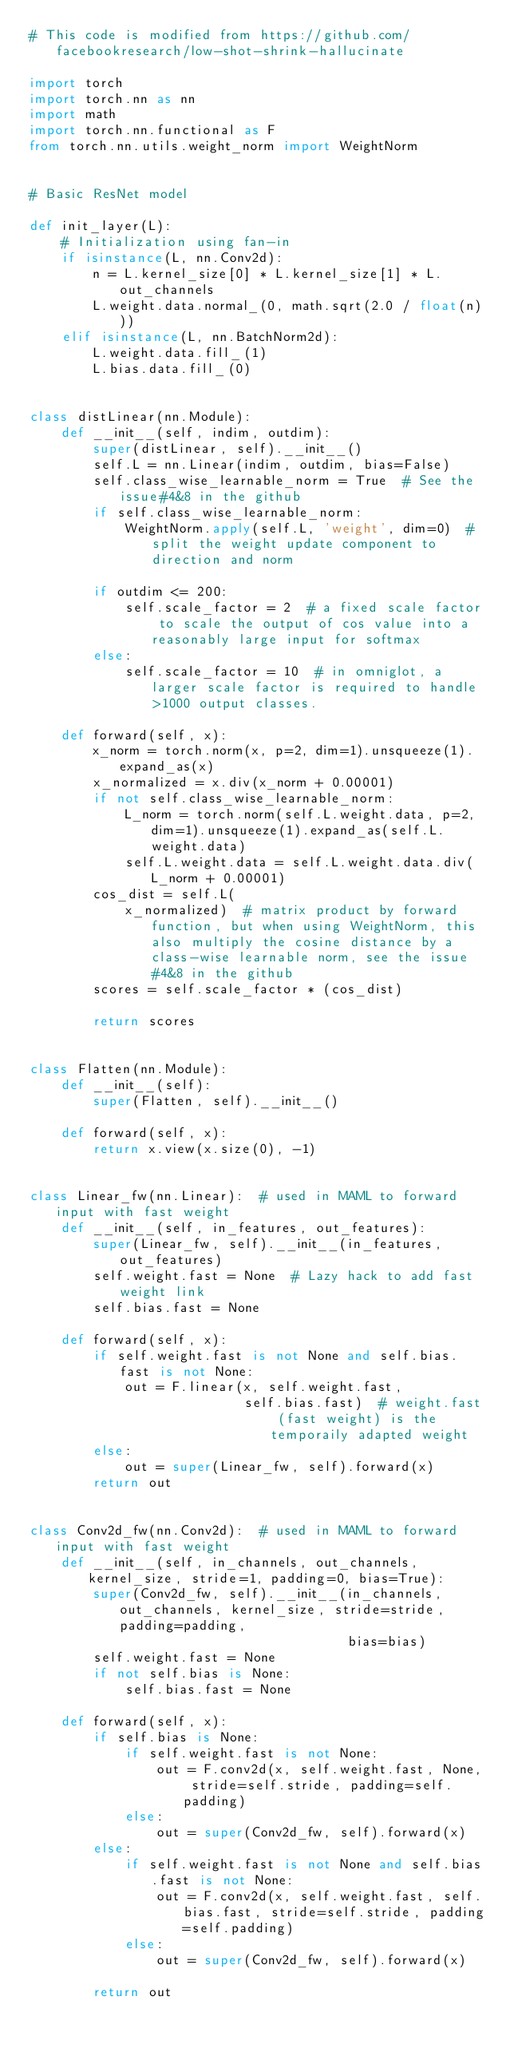Convert code to text. <code><loc_0><loc_0><loc_500><loc_500><_Python_># This code is modified from https://github.com/facebookresearch/low-shot-shrink-hallucinate

import torch
import torch.nn as nn
import math
import torch.nn.functional as F
from torch.nn.utils.weight_norm import WeightNorm


# Basic ResNet model

def init_layer(L):
    # Initialization using fan-in
    if isinstance(L, nn.Conv2d):
        n = L.kernel_size[0] * L.kernel_size[1] * L.out_channels
        L.weight.data.normal_(0, math.sqrt(2.0 / float(n)))
    elif isinstance(L, nn.BatchNorm2d):
        L.weight.data.fill_(1)
        L.bias.data.fill_(0)


class distLinear(nn.Module):
    def __init__(self, indim, outdim):
        super(distLinear, self).__init__()
        self.L = nn.Linear(indim, outdim, bias=False)
        self.class_wise_learnable_norm = True  # See the issue#4&8 in the github
        if self.class_wise_learnable_norm:
            WeightNorm.apply(self.L, 'weight', dim=0)  # split the weight update component to direction and norm

        if outdim <= 200:
            self.scale_factor = 2  # a fixed scale factor to scale the output of cos value into a reasonably large input for softmax
        else:
            self.scale_factor = 10  # in omniglot, a larger scale factor is required to handle >1000 output classes.

    def forward(self, x):
        x_norm = torch.norm(x, p=2, dim=1).unsqueeze(1).expand_as(x)
        x_normalized = x.div(x_norm + 0.00001)
        if not self.class_wise_learnable_norm:
            L_norm = torch.norm(self.L.weight.data, p=2, dim=1).unsqueeze(1).expand_as(self.L.weight.data)
            self.L.weight.data = self.L.weight.data.div(L_norm + 0.00001)
        cos_dist = self.L(
            x_normalized)  # matrix product by forward function, but when using WeightNorm, this also multiply the cosine distance by a class-wise learnable norm, see the issue#4&8 in the github
        scores = self.scale_factor * (cos_dist)

        return scores


class Flatten(nn.Module):
    def __init__(self):
        super(Flatten, self).__init__()

    def forward(self, x):
        return x.view(x.size(0), -1)


class Linear_fw(nn.Linear):  # used in MAML to forward input with fast weight
    def __init__(self, in_features, out_features):
        super(Linear_fw, self).__init__(in_features, out_features)
        self.weight.fast = None  # Lazy hack to add fast weight link
        self.bias.fast = None

    def forward(self, x):
        if self.weight.fast is not None and self.bias.fast is not None:
            out = F.linear(x, self.weight.fast,
                           self.bias.fast)  # weight.fast (fast weight) is the temporaily adapted weight
        else:
            out = super(Linear_fw, self).forward(x)
        return out


class Conv2d_fw(nn.Conv2d):  # used in MAML to forward input with fast weight
    def __init__(self, in_channels, out_channels, kernel_size, stride=1, padding=0, bias=True):
        super(Conv2d_fw, self).__init__(in_channels, out_channels, kernel_size, stride=stride, padding=padding,
                                        bias=bias)
        self.weight.fast = None
        if not self.bias is None:
            self.bias.fast = None

    def forward(self, x):
        if self.bias is None:
            if self.weight.fast is not None:
                out = F.conv2d(x, self.weight.fast, None, stride=self.stride, padding=self.padding)
            else:
                out = super(Conv2d_fw, self).forward(x)
        else:
            if self.weight.fast is not None and self.bias.fast is not None:
                out = F.conv2d(x, self.weight.fast, self.bias.fast, stride=self.stride, padding=self.padding)
            else:
                out = super(Conv2d_fw, self).forward(x)

        return out

</code> 